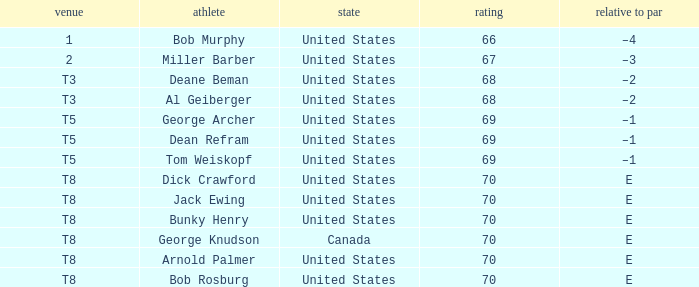Which nation does george archer belong to? United States. 